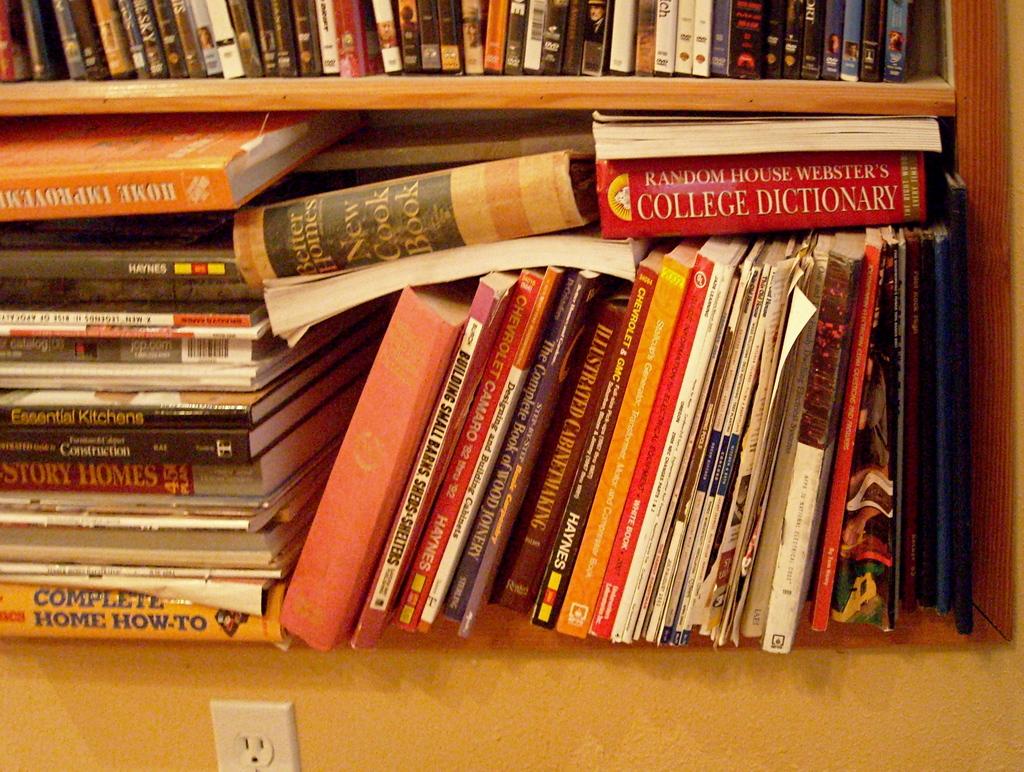Is there a book about building barns?
Offer a very short reply. Yes. 